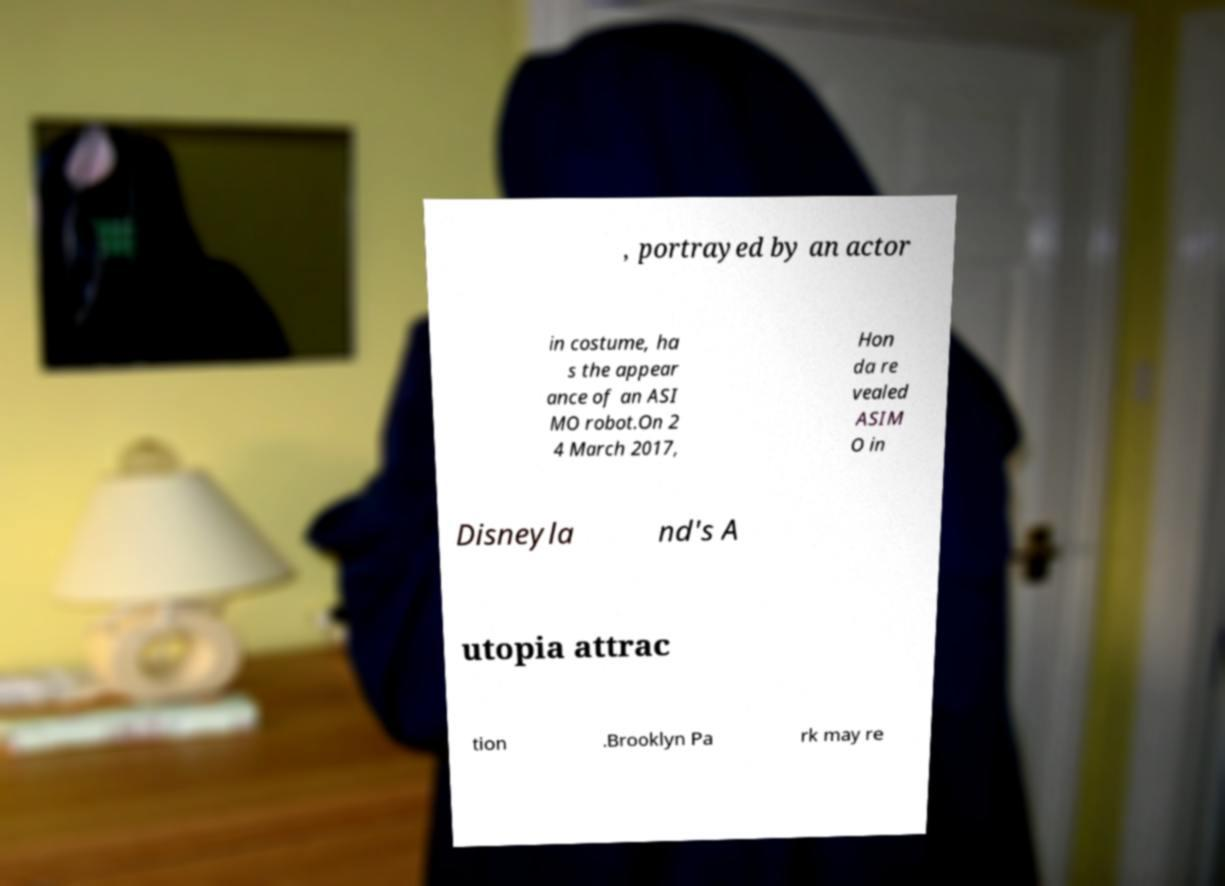Please read and relay the text visible in this image. What does it say? , portrayed by an actor in costume, ha s the appear ance of an ASI MO robot.On 2 4 March 2017, Hon da re vealed ASIM O in Disneyla nd's A utopia attrac tion .Brooklyn Pa rk may re 